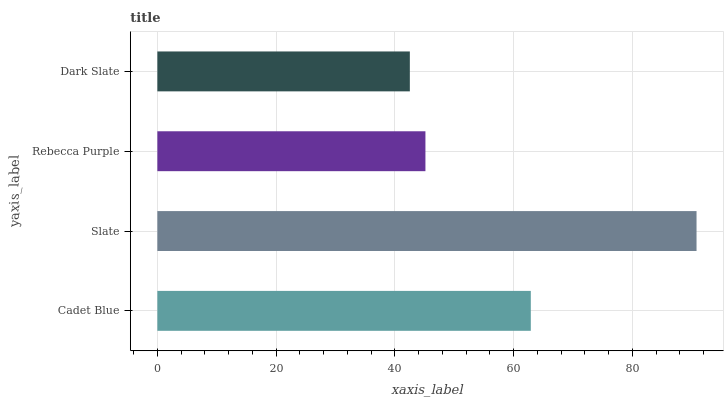Is Dark Slate the minimum?
Answer yes or no. Yes. Is Slate the maximum?
Answer yes or no. Yes. Is Rebecca Purple the minimum?
Answer yes or no. No. Is Rebecca Purple the maximum?
Answer yes or no. No. Is Slate greater than Rebecca Purple?
Answer yes or no. Yes. Is Rebecca Purple less than Slate?
Answer yes or no. Yes. Is Rebecca Purple greater than Slate?
Answer yes or no. No. Is Slate less than Rebecca Purple?
Answer yes or no. No. Is Cadet Blue the high median?
Answer yes or no. Yes. Is Rebecca Purple the low median?
Answer yes or no. Yes. Is Dark Slate the high median?
Answer yes or no. No. Is Dark Slate the low median?
Answer yes or no. No. 